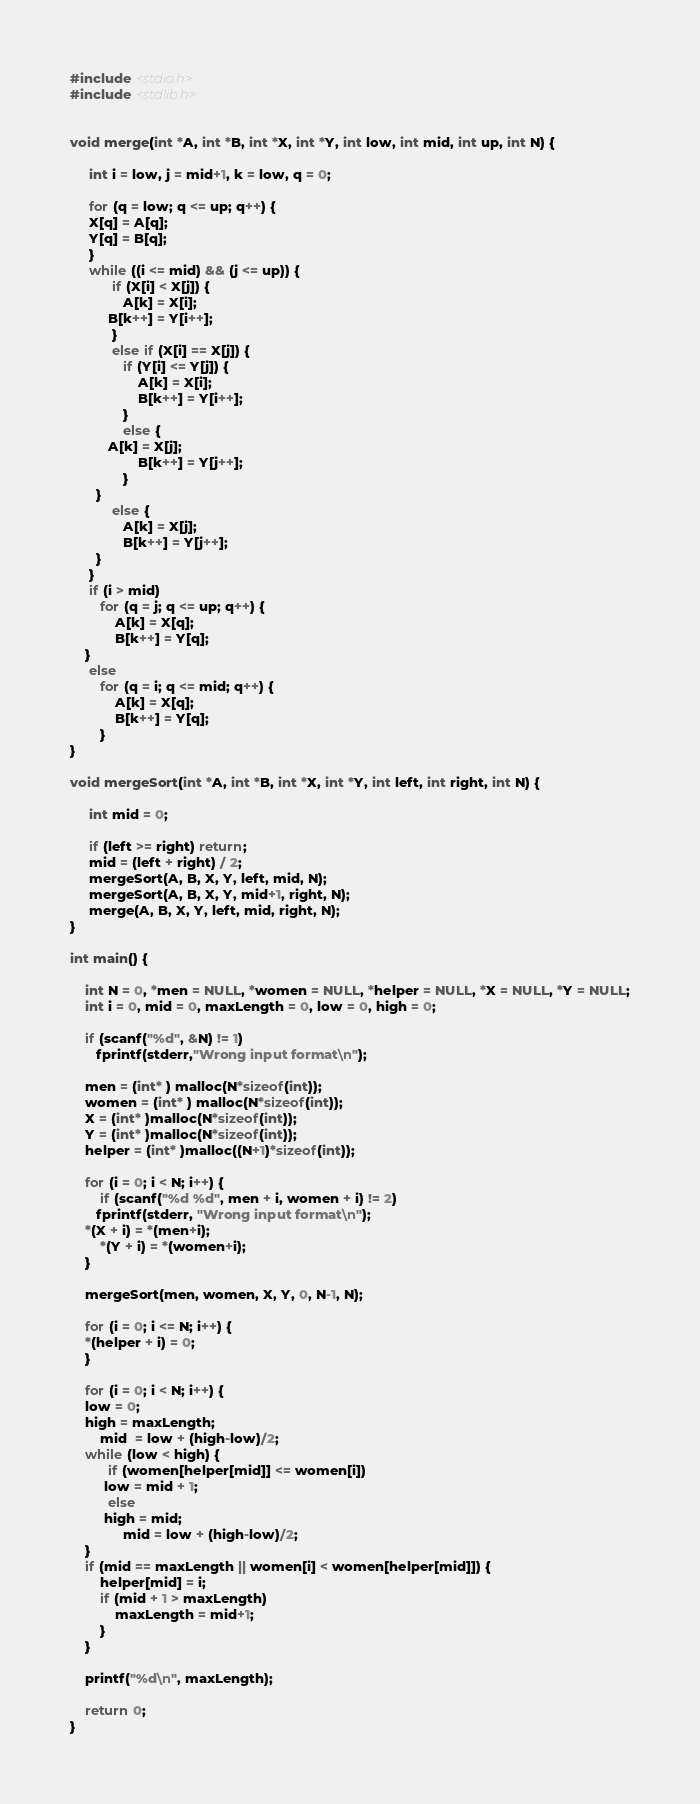<code> <loc_0><loc_0><loc_500><loc_500><_C_>#include <stdio.h>
#include <stdlib.h>


void merge(int *A, int *B, int *X, int *Y, int low, int mid, int up, int N) {

     int i = low, j = mid+1, k = low, q = 0;
	
     for (q = low; q <= up; q++) {
	 X[q] = A[q];
	 Y[q] = B[q];
     }
     while ((i <= mid) && (j <= up)) {
           if (X[i] < X[j]) {
              A[k] = X[i];
	      B[k++] = Y[i++];
           }
           else if (X[i] == X[j]) {
              if (Y[i] <= Y[j]) {
                  A[k] = X[i];
                  B[k++] = Y[i++];
              }
              else {
		  A[k] = X[j];
                  B[k++] = Y[j++];
              }
	   }
           else { 
              A[k] = X[j];
              B[k++] = Y[j++];
	   }
     }
     if (i > mid)
        for (q = j; q <= up; q++) {
            A[k] = X[q];
            B[k++] = Y[q];
	}
     else
        for (q = i; q <= mid; q++) {
            A[k] = X[q];
            B[k++] = Y[q];
        }
}

void mergeSort(int *A, int *B, int *X, int *Y, int left, int right, int N) {
	
     int mid = 0;
	
     if (left >= right) return;
     mid = (left + right) / 2;
     mergeSort(A, B, X, Y, left, mid, N);
     mergeSort(A, B, X, Y, mid+1, right, N);
     merge(A, B, X, Y, left, mid, right, N); 
}

int main() {
    
    int N = 0, *men = NULL, *women = NULL, *helper = NULL, *X = NULL, *Y = NULL;
    int i = 0, mid = 0, maxLength = 0, low = 0, high = 0;
    
    if (scanf("%d", &N) != 1)
       fprintf(stderr,"Wrong input format\n");

    men = (int* ) malloc(N*sizeof(int));
    women = (int* ) malloc(N*sizeof(int));
    X = (int* )malloc(N*sizeof(int));
    Y = (int* )malloc(N*sizeof(int));
    helper = (int* )malloc((N+1)*sizeof(int));

    for (i = 0; i < N; i++) {
        if (scanf("%d %d", men + i, women + i) != 2)
	   fprintf(stderr, "Wrong input format\n");
	*(X + i) = *(men+i);
        *(Y + i) = *(women+i); 
    }

    mergeSort(men, women, X, Y, 0, N-1, N);

    for (i = 0; i <= N; i++) {
	*(helper + i) = 0;
    }

    for (i = 0; i < N; i++) {
	low = 0;
	high = maxLength;
        mid  = low + (high-low)/2;
	while (low < high) {
	      if (women[helper[mid]] <= women[i])
		 low = mid + 1;
	      else
		 high = mid;
              mid = low + (high-low)/2; 
	}
	if (mid == maxLength || women[i] < women[helper[mid]]) {
	    helper[mid] = i;
	    if (mid + 1 > maxLength)
	        maxLength = mid+1;
        }
    }

    printf("%d\n", maxLength);
       
    return 0;
}
</code> 